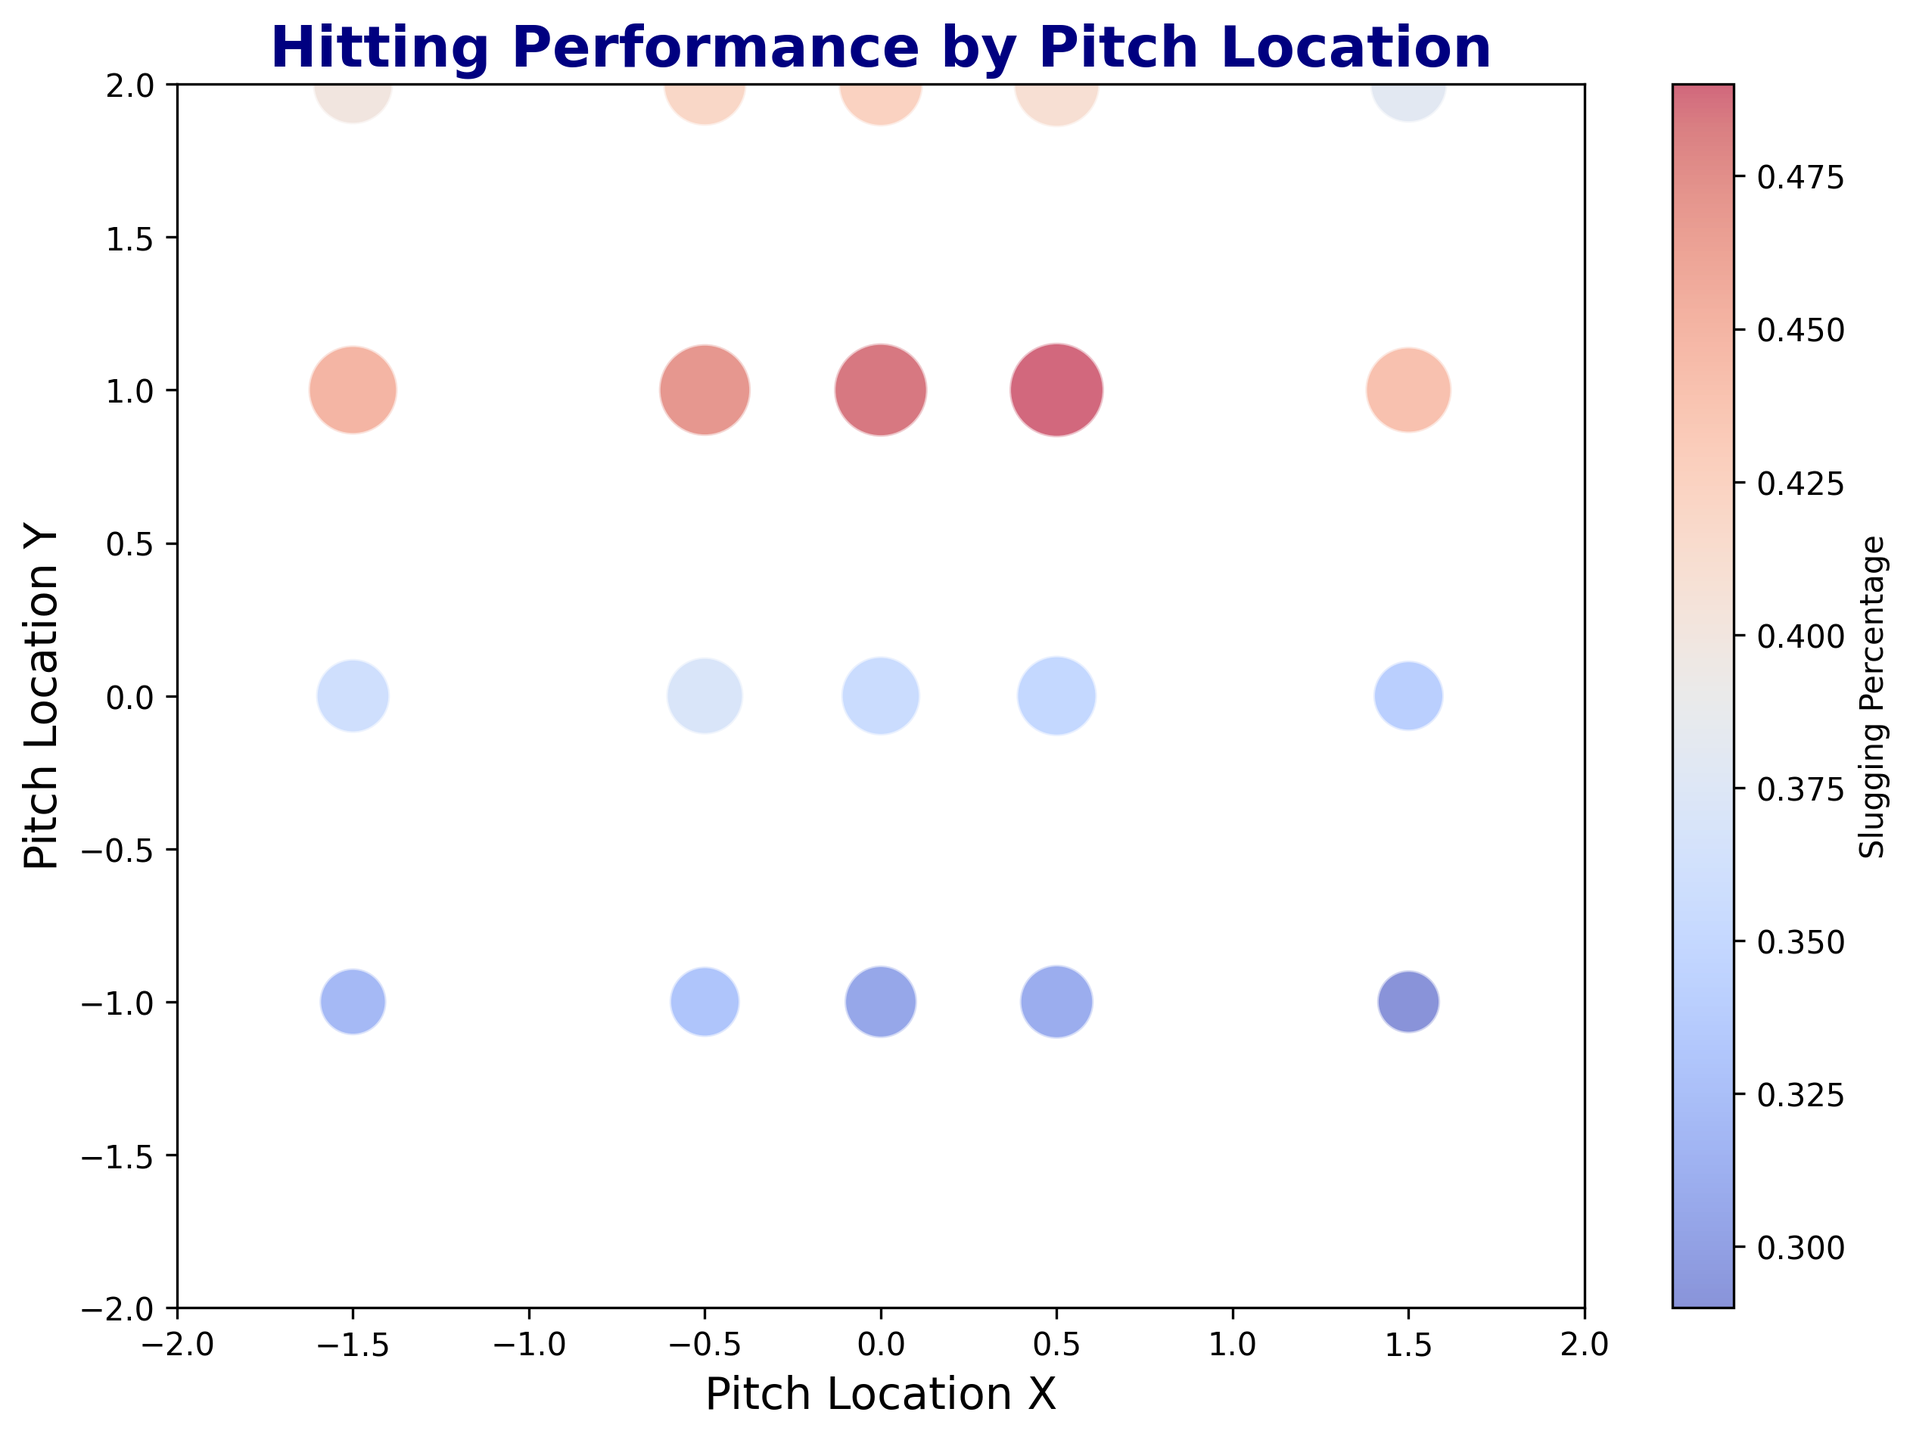Which pitch location has the highest contact rate? The bubble with the largest size indicates the highest contact rate. By observing the plot, the largest bubble is located at (0.5, 1.0).
Answer: (0.5, 1.0) Which pitch location has the lowest slugging percentage? The color scale indicates the slugging percentage, with cooler colors representing lower values. The bubble with the coolest color is located at (1.5, -1.0).
Answer: (1.5, -1.0) Compare the contact rates between pitch locations (-1.5, 1.0) and (1.5, -1.0). Which is higher? The bubble size at (-1.5, 1.0) is larger than the bubble at (1.5, -1.0), indicating a higher contact rate.
Answer: (-1.5, 1.0) What is the average slugging percentage for pitches located along the X=0 axis? The pitch locations along X=0 are (0, 2.0), (0, 1.0), (0, 0.0), and (0, -1.0). Their slugging percentages are 0.425, 0.485, 0.355, and 0.305 respectively. Average = (0.425 + 0.485 + 0.355 + 0.305) / 4 = 0.3925
Answer: 0.3925 Which pitch location combines the highest slugging percentage with a contact rate greater than 0.85? Observing both bubble size and color, the bubble at (-0.5, 1.0) has a contact rate of 0.85 and a slugging percentage of 0.470. The bubble at (0.5, 1.0) has a slightly higher contact rate of 0.90 and a slugging percentage of 0.490. Therefore, the location (0.5, 1.0) combines both the highest slugging percentage and a contact rate greater than 0.85.
Answer: (0.5, 1.0) Does pitch location (1.5, 0.0) have a higher contact rate or slugging percentage? The contact rate at (1.5, 0.0) is associated with the bubble size, which is smaller. The slugging percentage is associated with the bubble color, which indicates a lower slugging percentage. Comparing the values, contact rate is 0.50 and slugging percentage is 0.340, so the contact rate is higher.
Answer: Contact rate Assess the contact rate and slugging percentage performance at the extreme pitch location (-1.5, -1.0). Are both metrics low or high? The bubble located at (-1.5, -1.0) is relatively small and has a cooler color. The contact rate is 0.45, and the slugging percentage is 0.320, both of which are on the lower end of the scale.
Answer: Both are low Between the pitch locations (0, 1.0) and (1.5, 1.0), which has a greater contact rate and which has a greater slugging percentage? The bubble at (0, 1.0) has a larger size indicating higher contact rate and a warmer color indicating higher slugging percentage. The contact rates are 0.88 vs 0.75 and the slugging percentages are 0.485 vs 0.440 respectively.
Answer: (0, 1.0) for both 